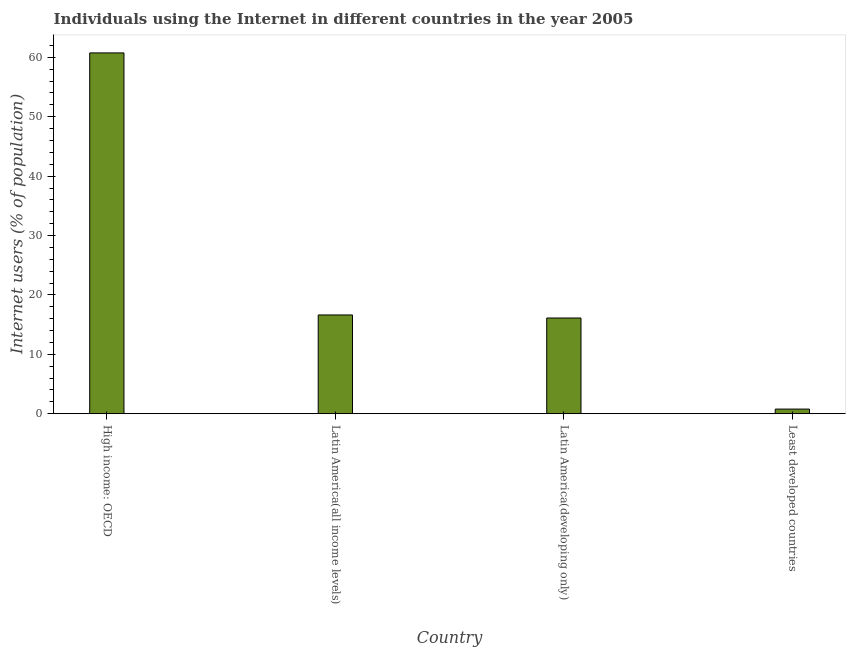Does the graph contain grids?
Give a very brief answer. No. What is the title of the graph?
Make the answer very short. Individuals using the Internet in different countries in the year 2005. What is the label or title of the Y-axis?
Your response must be concise. Internet users (% of population). What is the number of internet users in Latin America(all income levels)?
Offer a terse response. 16.63. Across all countries, what is the maximum number of internet users?
Your answer should be compact. 60.74. Across all countries, what is the minimum number of internet users?
Keep it short and to the point. 0.78. In which country was the number of internet users maximum?
Offer a terse response. High income: OECD. In which country was the number of internet users minimum?
Keep it short and to the point. Least developed countries. What is the sum of the number of internet users?
Keep it short and to the point. 94.27. What is the difference between the number of internet users in High income: OECD and Latin America(all income levels)?
Make the answer very short. 44.11. What is the average number of internet users per country?
Offer a terse response. 23.57. What is the median number of internet users?
Provide a short and direct response. 16.37. In how many countries, is the number of internet users greater than 46 %?
Give a very brief answer. 1. What is the ratio of the number of internet users in High income: OECD to that in Least developed countries?
Keep it short and to the point. 77.45. Is the number of internet users in Latin America(all income levels) less than that in Least developed countries?
Offer a terse response. No. Is the difference between the number of internet users in High income: OECD and Least developed countries greater than the difference between any two countries?
Provide a short and direct response. Yes. What is the difference between the highest and the second highest number of internet users?
Keep it short and to the point. 44.11. What is the difference between the highest and the lowest number of internet users?
Your answer should be very brief. 59.96. In how many countries, is the number of internet users greater than the average number of internet users taken over all countries?
Offer a very short reply. 1. What is the Internet users (% of population) of High income: OECD?
Offer a terse response. 60.74. What is the Internet users (% of population) in Latin America(all income levels)?
Offer a very short reply. 16.63. What is the Internet users (% of population) in Latin America(developing only)?
Keep it short and to the point. 16.12. What is the Internet users (% of population) of Least developed countries?
Offer a terse response. 0.78. What is the difference between the Internet users (% of population) in High income: OECD and Latin America(all income levels)?
Provide a short and direct response. 44.11. What is the difference between the Internet users (% of population) in High income: OECD and Latin America(developing only)?
Provide a short and direct response. 44.63. What is the difference between the Internet users (% of population) in High income: OECD and Least developed countries?
Your response must be concise. 59.96. What is the difference between the Internet users (% of population) in Latin America(all income levels) and Latin America(developing only)?
Provide a succinct answer. 0.51. What is the difference between the Internet users (% of population) in Latin America(all income levels) and Least developed countries?
Ensure brevity in your answer.  15.85. What is the difference between the Internet users (% of population) in Latin America(developing only) and Least developed countries?
Ensure brevity in your answer.  15.33. What is the ratio of the Internet users (% of population) in High income: OECD to that in Latin America(all income levels)?
Ensure brevity in your answer.  3.65. What is the ratio of the Internet users (% of population) in High income: OECD to that in Latin America(developing only)?
Give a very brief answer. 3.77. What is the ratio of the Internet users (% of population) in High income: OECD to that in Least developed countries?
Your answer should be compact. 77.45. What is the ratio of the Internet users (% of population) in Latin America(all income levels) to that in Latin America(developing only)?
Keep it short and to the point. 1.03. What is the ratio of the Internet users (% of population) in Latin America(all income levels) to that in Least developed countries?
Provide a succinct answer. 21.2. What is the ratio of the Internet users (% of population) in Latin America(developing only) to that in Least developed countries?
Provide a short and direct response. 20.55. 